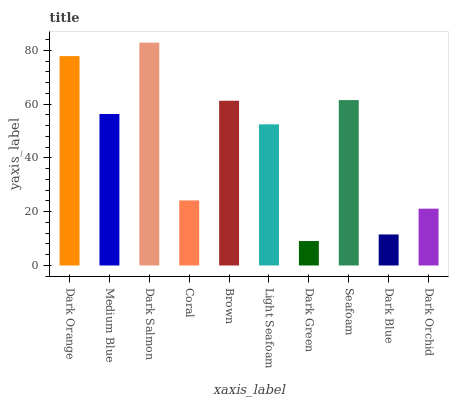Is Dark Green the minimum?
Answer yes or no. Yes. Is Dark Salmon the maximum?
Answer yes or no. Yes. Is Medium Blue the minimum?
Answer yes or no. No. Is Medium Blue the maximum?
Answer yes or no. No. Is Dark Orange greater than Medium Blue?
Answer yes or no. Yes. Is Medium Blue less than Dark Orange?
Answer yes or no. Yes. Is Medium Blue greater than Dark Orange?
Answer yes or no. No. Is Dark Orange less than Medium Blue?
Answer yes or no. No. Is Medium Blue the high median?
Answer yes or no. Yes. Is Light Seafoam the low median?
Answer yes or no. Yes. Is Dark Green the high median?
Answer yes or no. No. Is Seafoam the low median?
Answer yes or no. No. 